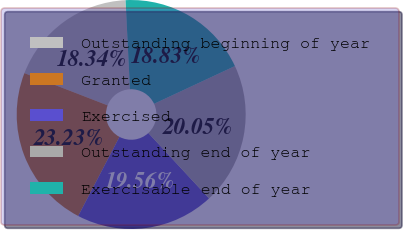Convert chart to OTSL. <chart><loc_0><loc_0><loc_500><loc_500><pie_chart><fcel>Outstanding beginning of year<fcel>Granted<fcel>Exercised<fcel>Outstanding end of year<fcel>Exercisable end of year<nl><fcel>18.34%<fcel>23.23%<fcel>19.56%<fcel>20.05%<fcel>18.83%<nl></chart> 